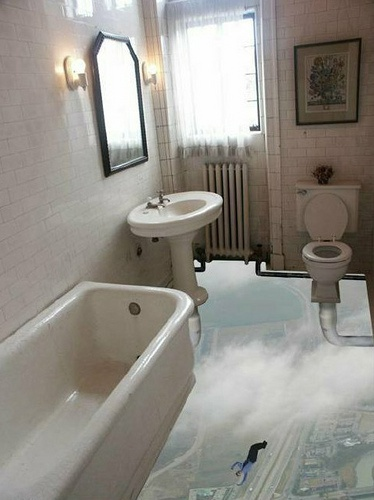Describe the objects in this image and their specific colors. I can see toilet in gray and black tones, sink in gray, lightgray, and darkgray tones, people in gray, black, and darkgray tones, and potted plant in gray, black, and maroon tones in this image. 